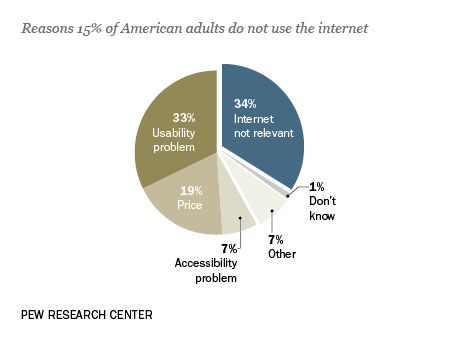Specify some key components in this picture. The response to the question 'What is 33%?' is a usability problem. The ratio between the amount of internet that is not relevant and the price is 1.78947...". 